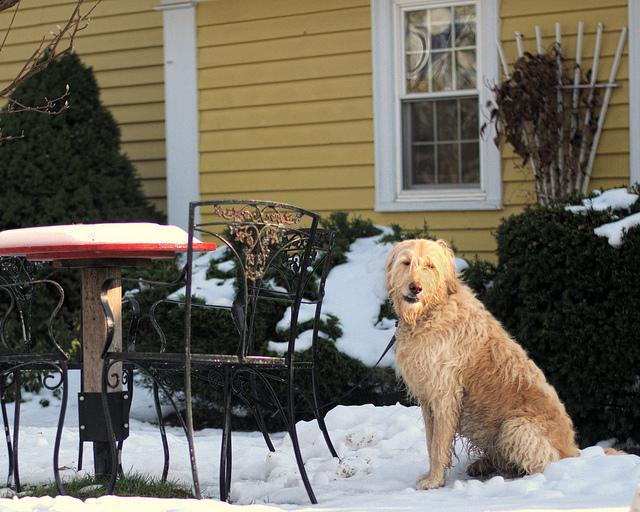What famous animal does this one most closely resemble? benji 